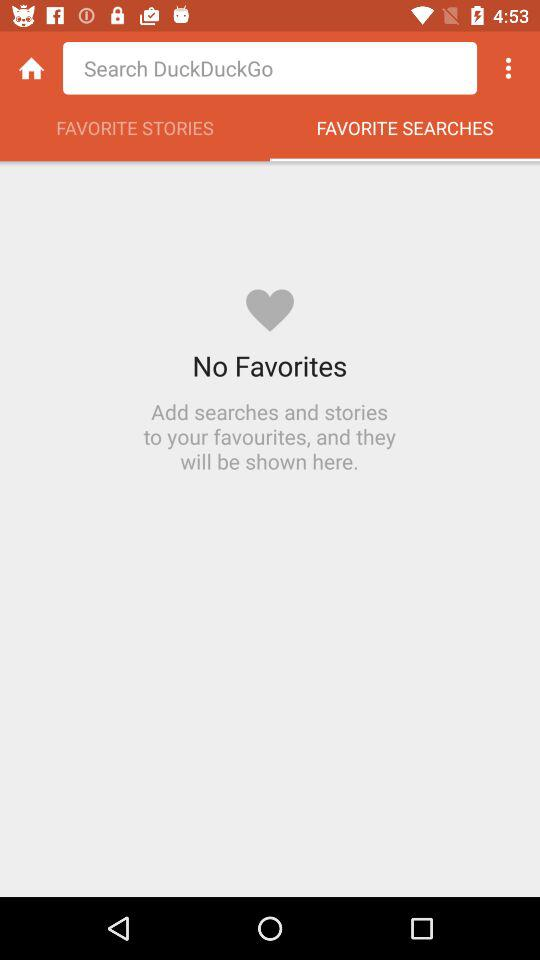Which tab has been selected? The selected tab is "FAVORITE SEARCHES". 